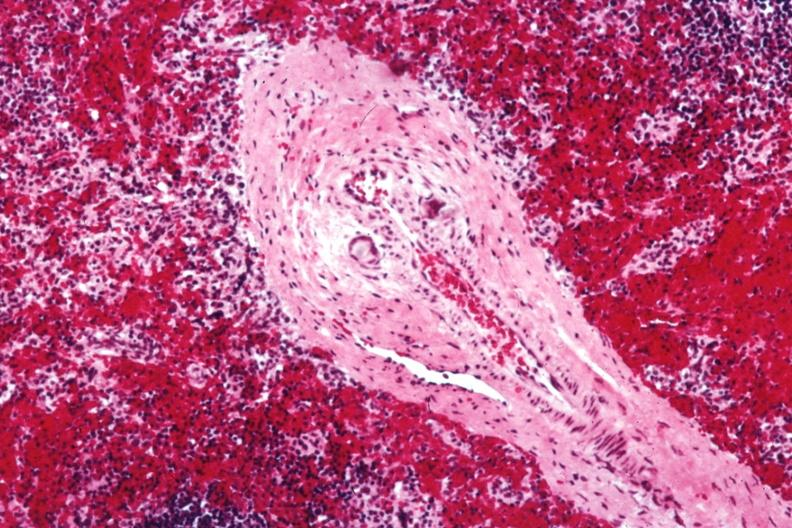s heart thought to be silicon?
Answer the question using a single word or phrase. No 